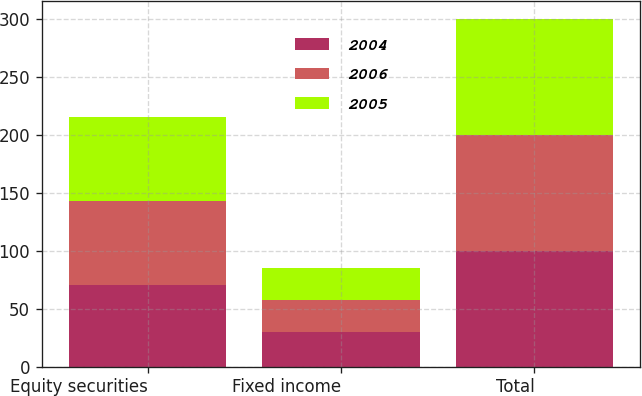Convert chart to OTSL. <chart><loc_0><loc_0><loc_500><loc_500><stacked_bar_chart><ecel><fcel>Equity securities<fcel>Fixed income<fcel>Total<nl><fcel>2004<fcel>70<fcel>30<fcel>100<nl><fcel>2006<fcel>73<fcel>27<fcel>100<nl><fcel>2005<fcel>72<fcel>28<fcel>100<nl></chart> 